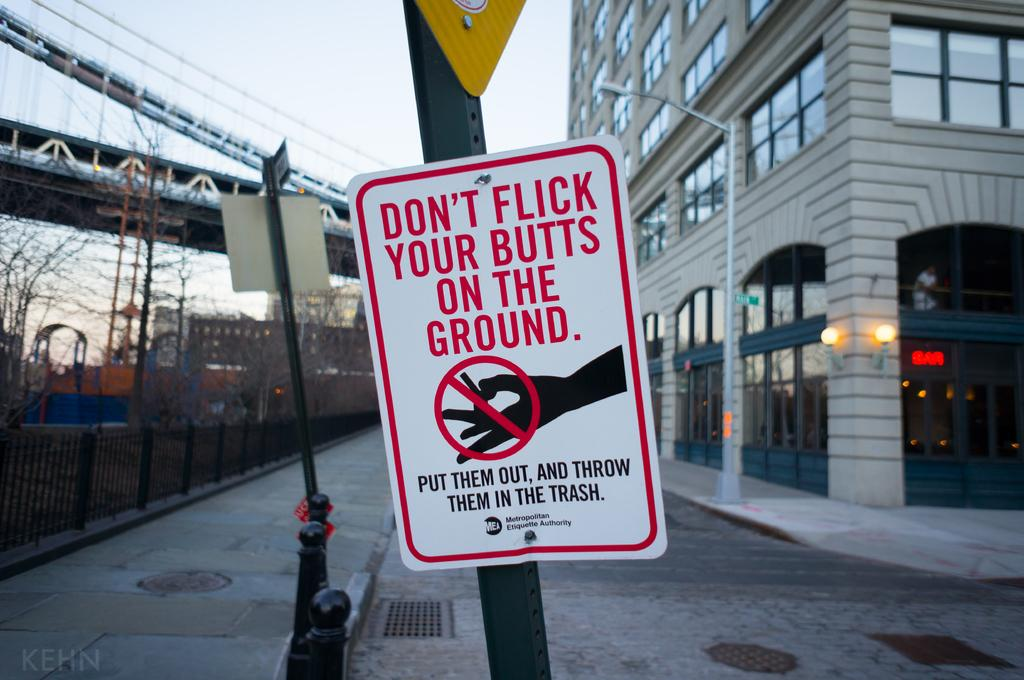<image>
Summarize the visual content of the image. A public sign discouraging smokers from throwing cigarette butts on the ground. 